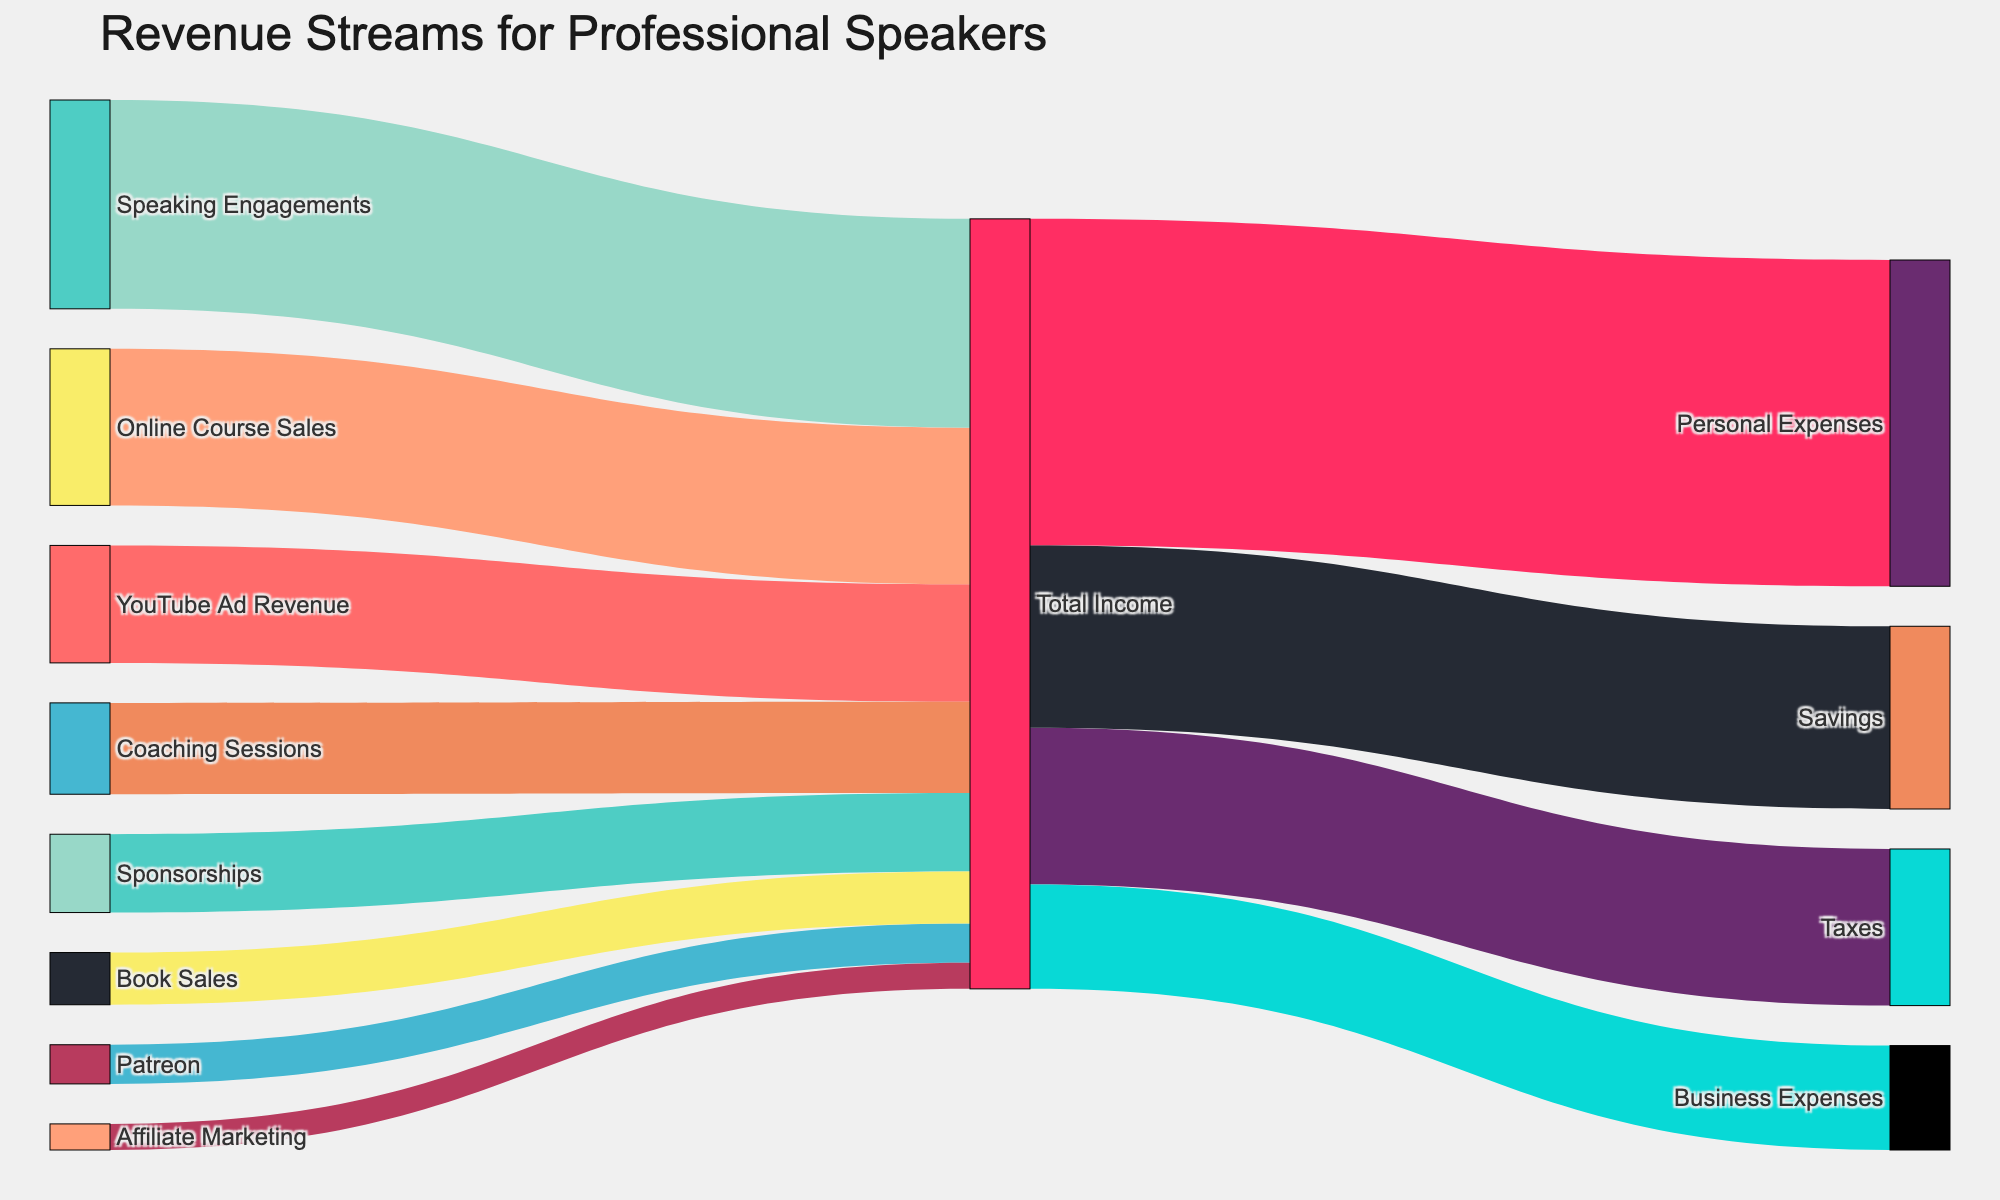What is the title of this Sankey diagram? The title is placed at the top of the Sankey diagram, indicating the main focus of the visualization.
Answer: Revenue Streams for Professional Speakers Which revenue stream contributes the most to the total income? By inspecting the width of the links flowing into "Total Income," the largest link corresponds to "Speaking Engagements."
Answer: Speaking Engagements How much total income is attributed to online course sales and book sales combined? The value for Online Course Sales is 60,000, and Book Sales is 20,000. Adding these together gives 60,000 + 20,000.
Answer: 80,000 Which expense category has the largest allocation from the total income? Among the links originating from "Total Income," the widest link leads to "Personal Expenses."
Answer: Personal Expenses How does the income from YouTube ad revenue compare to Patreon support? YouTube Ad Revenue is 45,000, while Patreon is 15,000. Comparing these values shows that YouTube Ad Revenue is greater.
Answer: YouTube Ad Revenue is greater What is the total revenue generated from revenue streams excluding speaking engagements? Summing the values for all revenue streams except Speaking Engagements (Online Course Sales: 60,000, YouTube Ad Revenue: 45,000, Sponsorships: 30,000, Patreon: 15,000, Book Sales: 20,000, Coaching Sessions: 35,000, and Affiliate Marketing: 10,000) results in 210,000.
Answer: 210,000 What fraction of total income is allocated to savings? The link from Total Income to Savings shows a value of 70,000. With total revenue at 275,000, the fraction is 70,000 / 275,000.
Answer: 70,000 / 275,000 Which income stream has a lower contribution, Affiliate Marketing or Book Sales? By observing the widths of the links, Affiliate Marketing (10,000) is less than Book Sales (20,000).
Answer: Affiliate Marketing What is the difference between the revenue from coaching sessions and sponsorships? The value for Coaching Sessions is 35,000 and for Sponsorships is 30,000. The difference is calculated as 35,000 - 30,000.
Answer: 5,000 Which color represents the link for coaching sessions? The color corresponding to Coaching Sessions link can be noted by visually identifying the colored link from "Coaching Sessions" to "Total Income."
Answer: Color of the Coaching Sessions link 